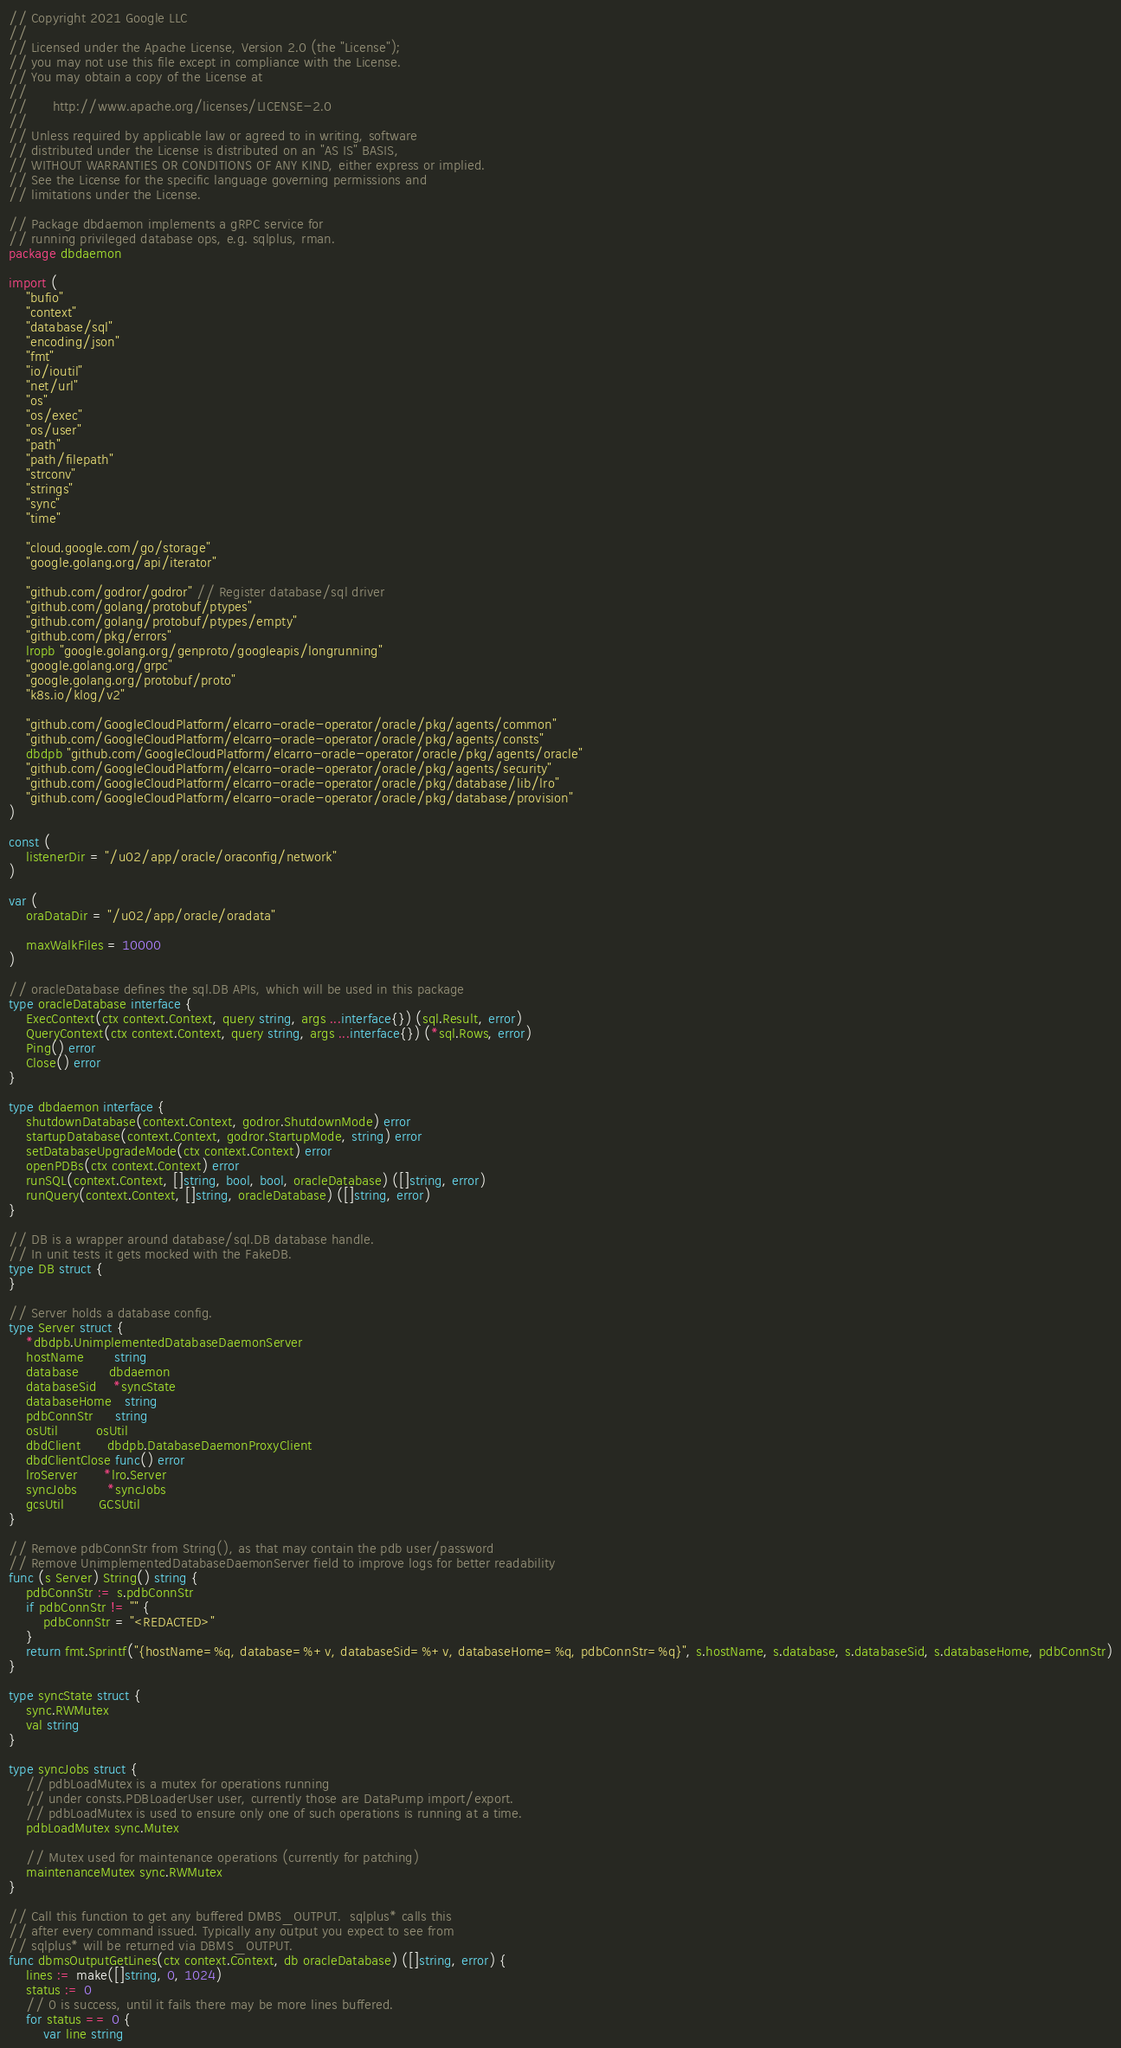Convert code to text. <code><loc_0><loc_0><loc_500><loc_500><_Go_>// Copyright 2021 Google LLC
//
// Licensed under the Apache License, Version 2.0 (the "License");
// you may not use this file except in compliance with the License.
// You may obtain a copy of the License at
//
//      http://www.apache.org/licenses/LICENSE-2.0
//
// Unless required by applicable law or agreed to in writing, software
// distributed under the License is distributed on an "AS IS" BASIS,
// WITHOUT WARRANTIES OR CONDITIONS OF ANY KIND, either express or implied.
// See the License for the specific language governing permissions and
// limitations under the License.

// Package dbdaemon implements a gRPC service for
// running privileged database ops, e.g. sqlplus, rman.
package dbdaemon

import (
	"bufio"
	"context"
	"database/sql"
	"encoding/json"
	"fmt"
	"io/ioutil"
	"net/url"
	"os"
	"os/exec"
	"os/user"
	"path"
	"path/filepath"
	"strconv"
	"strings"
	"sync"
	"time"

	"cloud.google.com/go/storage"
	"google.golang.org/api/iterator"

	"github.com/godror/godror" // Register database/sql driver
	"github.com/golang/protobuf/ptypes"
	"github.com/golang/protobuf/ptypes/empty"
	"github.com/pkg/errors"
	lropb "google.golang.org/genproto/googleapis/longrunning"
	"google.golang.org/grpc"
	"google.golang.org/protobuf/proto"
	"k8s.io/klog/v2"

	"github.com/GoogleCloudPlatform/elcarro-oracle-operator/oracle/pkg/agents/common"
	"github.com/GoogleCloudPlatform/elcarro-oracle-operator/oracle/pkg/agents/consts"
	dbdpb "github.com/GoogleCloudPlatform/elcarro-oracle-operator/oracle/pkg/agents/oracle"
	"github.com/GoogleCloudPlatform/elcarro-oracle-operator/oracle/pkg/agents/security"
	"github.com/GoogleCloudPlatform/elcarro-oracle-operator/oracle/pkg/database/lib/lro"
	"github.com/GoogleCloudPlatform/elcarro-oracle-operator/oracle/pkg/database/provision"
)

const (
	listenerDir = "/u02/app/oracle/oraconfig/network"
)

var (
	oraDataDir = "/u02/app/oracle/oradata"

	maxWalkFiles = 10000
)

// oracleDatabase defines the sql.DB APIs, which will be used in this package
type oracleDatabase interface {
	ExecContext(ctx context.Context, query string, args ...interface{}) (sql.Result, error)
	QueryContext(ctx context.Context, query string, args ...interface{}) (*sql.Rows, error)
	Ping() error
	Close() error
}

type dbdaemon interface {
	shutdownDatabase(context.Context, godror.ShutdownMode) error
	startupDatabase(context.Context, godror.StartupMode, string) error
	setDatabaseUpgradeMode(ctx context.Context) error
	openPDBs(ctx context.Context) error
	runSQL(context.Context, []string, bool, bool, oracleDatabase) ([]string, error)
	runQuery(context.Context, []string, oracleDatabase) ([]string, error)
}

// DB is a wrapper around database/sql.DB database handle.
// In unit tests it gets mocked with the FakeDB.
type DB struct {
}

// Server holds a database config.
type Server struct {
	*dbdpb.UnimplementedDatabaseDaemonServer
	hostName       string
	database       dbdaemon
	databaseSid    *syncState
	databaseHome   string
	pdbConnStr     string
	osUtil         osUtil
	dbdClient      dbdpb.DatabaseDaemonProxyClient
	dbdClientClose func() error
	lroServer      *lro.Server
	syncJobs       *syncJobs
	gcsUtil        GCSUtil
}

// Remove pdbConnStr from String(), as that may contain the pdb user/password
// Remove UnimplementedDatabaseDaemonServer field to improve logs for better readability
func (s Server) String() string {
	pdbConnStr := s.pdbConnStr
	if pdbConnStr != "" {
		pdbConnStr = "<REDACTED>"
	}
	return fmt.Sprintf("{hostName=%q, database=%+v, databaseSid=%+v, databaseHome=%q, pdbConnStr=%q}", s.hostName, s.database, s.databaseSid, s.databaseHome, pdbConnStr)
}

type syncState struct {
	sync.RWMutex
	val string
}

type syncJobs struct {
	// pdbLoadMutex is a mutex for operations running
	// under consts.PDBLoaderUser user, currently those are DataPump import/export.
	// pdbLoadMutex is used to ensure only one of such operations is running at a time.
	pdbLoadMutex sync.Mutex

	// Mutex used for maintenance operations (currently for patching)
	maintenanceMutex sync.RWMutex
}

// Call this function to get any buffered DMBS_OUTPUT.  sqlplus* calls this
// after every command issued. Typically any output you expect to see from
// sqlplus* will be returned via DBMS_OUTPUT.
func dbmsOutputGetLines(ctx context.Context, db oracleDatabase) ([]string, error) {
	lines := make([]string, 0, 1024)
	status := 0
	// 0 is success, until it fails there may be more lines buffered.
	for status == 0 {
		var line string</code> 